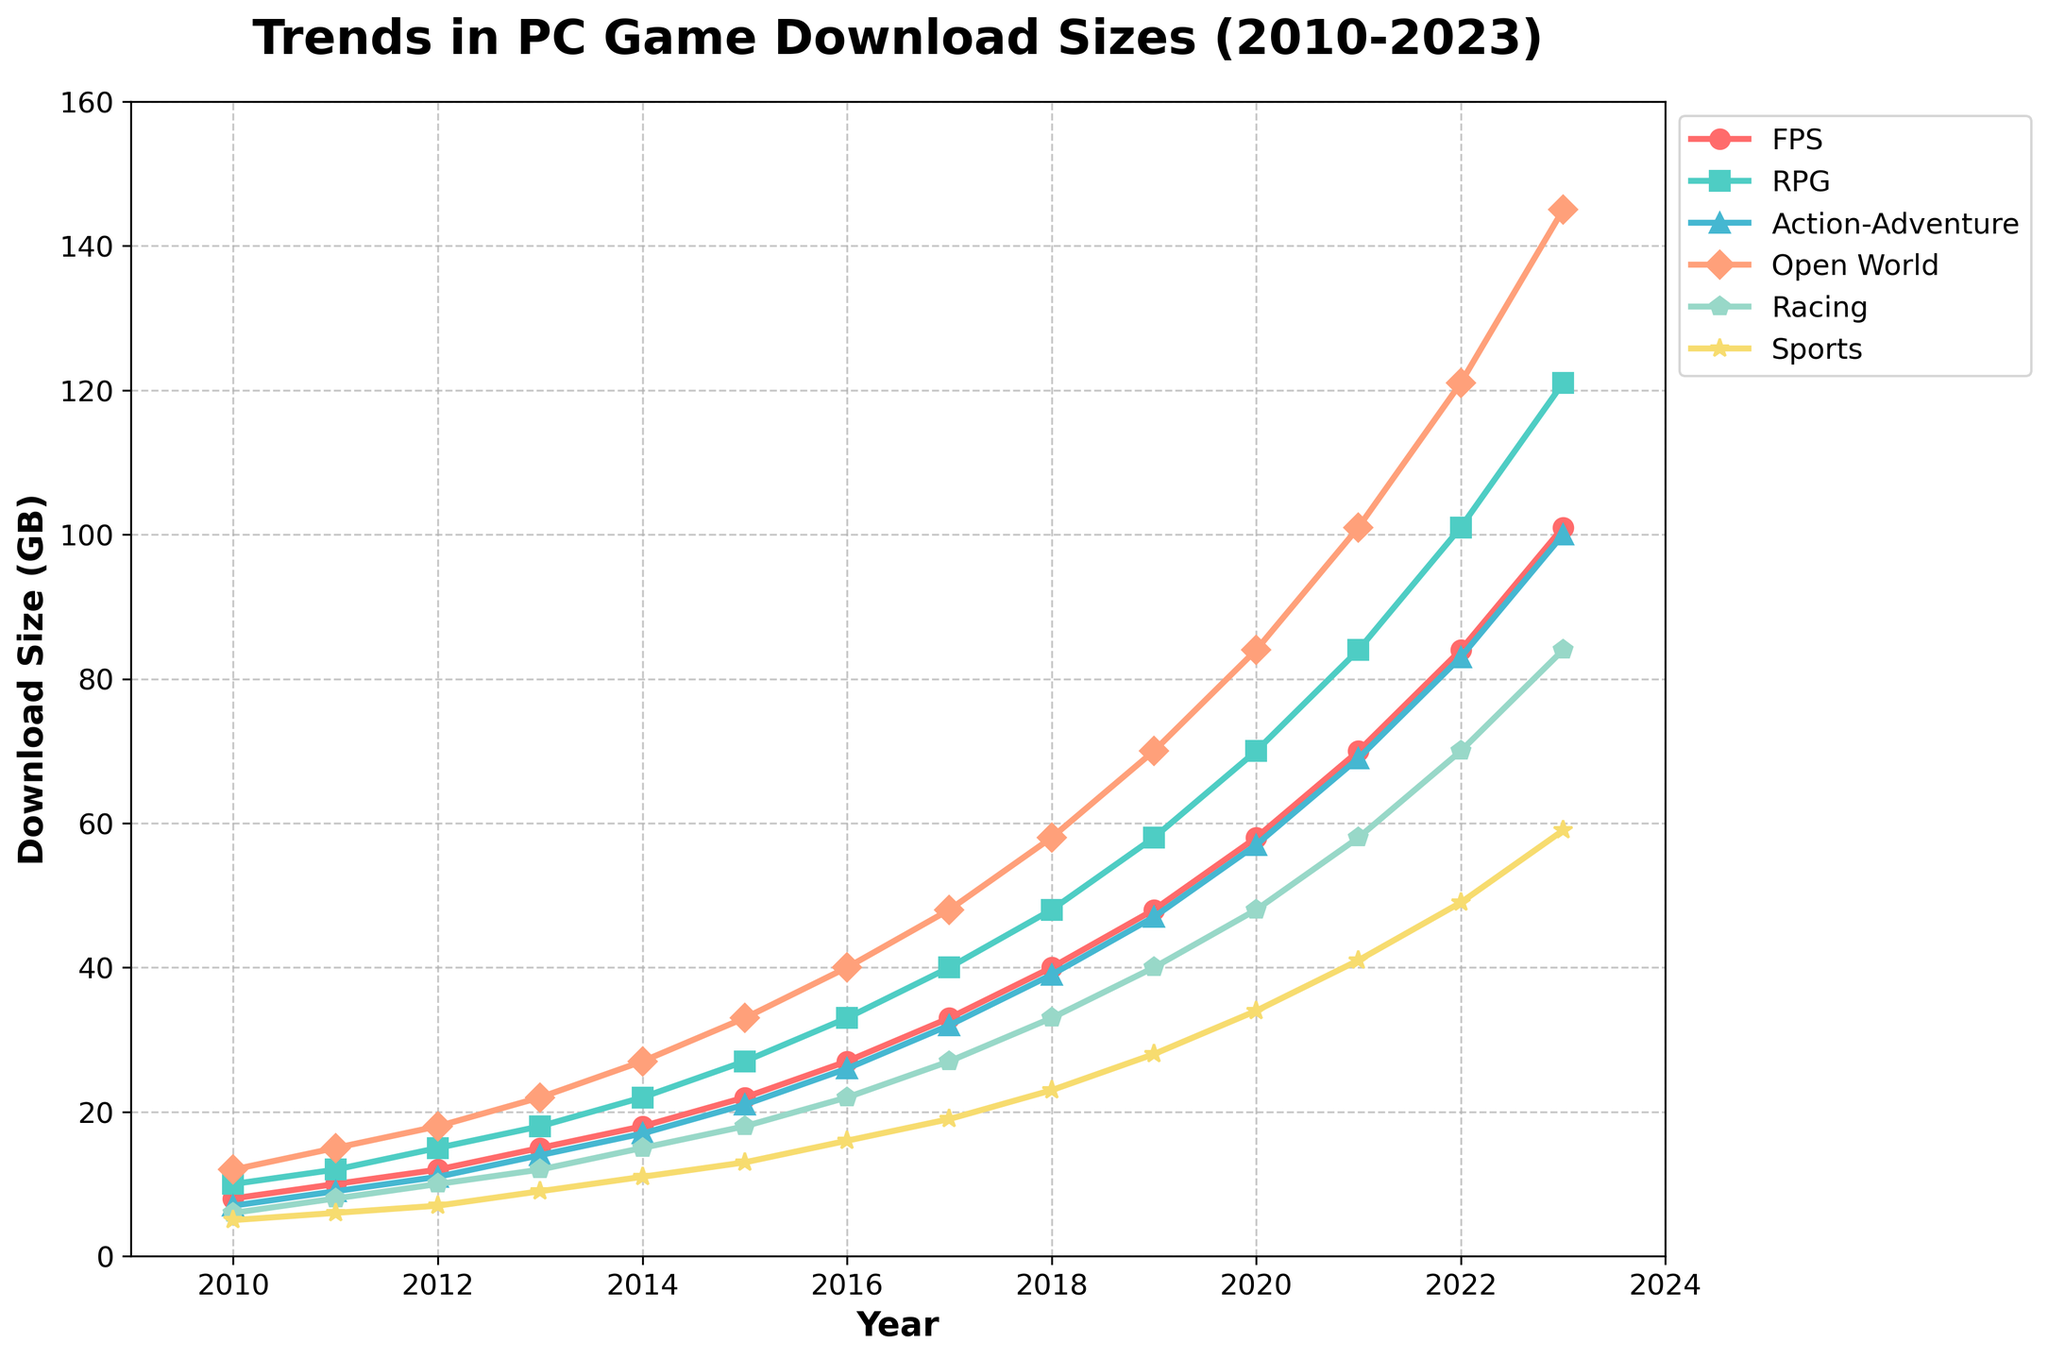Which genre showed the largest increase in download size from 2010 to 2023? Look at the trends for each genre from 2010 to 2023. Compare the increase by subtracting the 2010 value from the 2023 value for each genre. FPS increased from 8 GB to 101 GB (93 GB), RPG from 10 to 121 GB (111 GB), Action-Adventure from 7 to 100 GB (93 GB), Open World from 12 to 145 GB (133 GB), Racing from 6 to 84 GB (78 GB), and Sports from 5 to 59 GB (54 GB). The largest increase is for Open World, with an increase of 133 GB.
Answer: Open World Which year did RPGs first surpass a download size of 100 GB? Observe the RPG line and locate the first year where the download size exceeds 100 GB. The size surpasses 100 GB in 2022, where the value is 101 GB. It remains above this size in 2023 as well, which confirms the observation.
Answer: 2022 What is the average download size of Racing games from 2010 to 2023? Sum the Racing game sizes from 2010 to 2023 and divide by the number of years. The sizes are 6, 8, 10, 12, 15, 18, 22, 27, 33, 40, 48, 58, 70, and 84. The total sum is 451 GB. There are 14 years. 451 / 14 = 32.21 (rounded to two decimal places).
Answer: 32.21 In which year did Sports games reach a download size of approximately half of Open World games for that year? Identify the years where Sports game's size is close to half of Open World game's size using approximate comparison. In 2021, Sports games are 41 GB, and Open World games are 101 GB. 41 is approximately half of 101.
Answer: 2021 How do the download sizes of FPS and RPG games in 2015 compare? Look at the values for FPS and RPG games in 2015. FPS is 22 GB, and RPG is 27 GB, so RPG is 5 GB larger.
Answer: RPG is 5 GB larger What is the rate of increase per year for Open World games from 2010 to 2023? Calculate the total increase in Open World game size from 2010 to 2023, and then divide by the number of years. The size increases from 12 GB to 145 GB, a difference of 145 - 12 = 133 GB over 13 years. The rate is 133 / 13 ≈ 10.23 GB per year.
Answer: 10.23 GB per year Comparing the trend lines, which genre consistently had the smallest download sizes from 2010 to 2023? Observe the trend lines and identify the genre with the smallest size values over the years. Sports games have the smallest download sizes in every year from 2010 to 2023.
Answer: Sports In which year did Action-Adventure games exceed 50 GB in download size? Locate the first year where Action-Adventure games' size exceeds 50 GB. This occurs in 2018 when the size is 58 GB.
Answer: 2018 